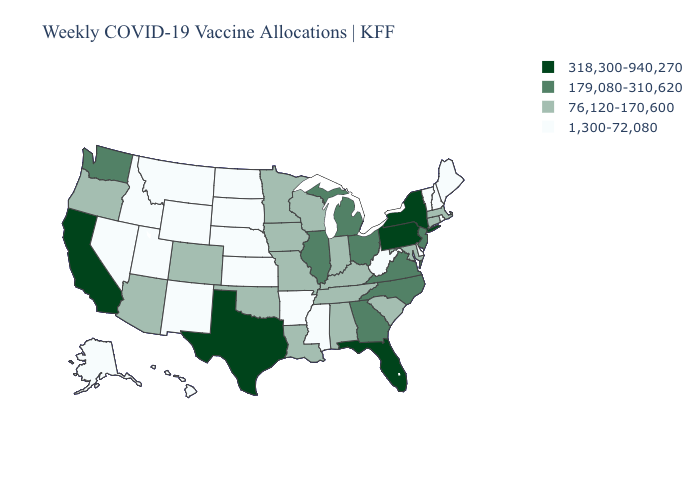How many symbols are there in the legend?
Write a very short answer. 4. What is the value of Maryland?
Write a very short answer. 76,120-170,600. Name the states that have a value in the range 179,080-310,620?
Give a very brief answer. Georgia, Illinois, Michigan, New Jersey, North Carolina, Ohio, Virginia, Washington. What is the value of New Hampshire?
Be succinct. 1,300-72,080. Among the states that border Nebraska , does Colorado have the lowest value?
Concise answer only. No. Among the states that border Tennessee , which have the lowest value?
Concise answer only. Arkansas, Mississippi. What is the lowest value in states that border Wisconsin?
Short answer required. 76,120-170,600. What is the highest value in the Northeast ?
Give a very brief answer. 318,300-940,270. Which states hav the highest value in the MidWest?
Give a very brief answer. Illinois, Michigan, Ohio. Name the states that have a value in the range 179,080-310,620?
Short answer required. Georgia, Illinois, Michigan, New Jersey, North Carolina, Ohio, Virginia, Washington. Is the legend a continuous bar?
Give a very brief answer. No. Name the states that have a value in the range 179,080-310,620?
Give a very brief answer. Georgia, Illinois, Michigan, New Jersey, North Carolina, Ohio, Virginia, Washington. What is the value of New Hampshire?
Be succinct. 1,300-72,080. What is the value of Washington?
Quick response, please. 179,080-310,620. What is the value of Wyoming?
Answer briefly. 1,300-72,080. 